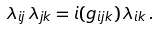<formula> <loc_0><loc_0><loc_500><loc_500>\lambda _ { i j } \, \lambda _ { j k } = i ( g _ { i j k } ) \, \lambda _ { i k } \, .</formula> 